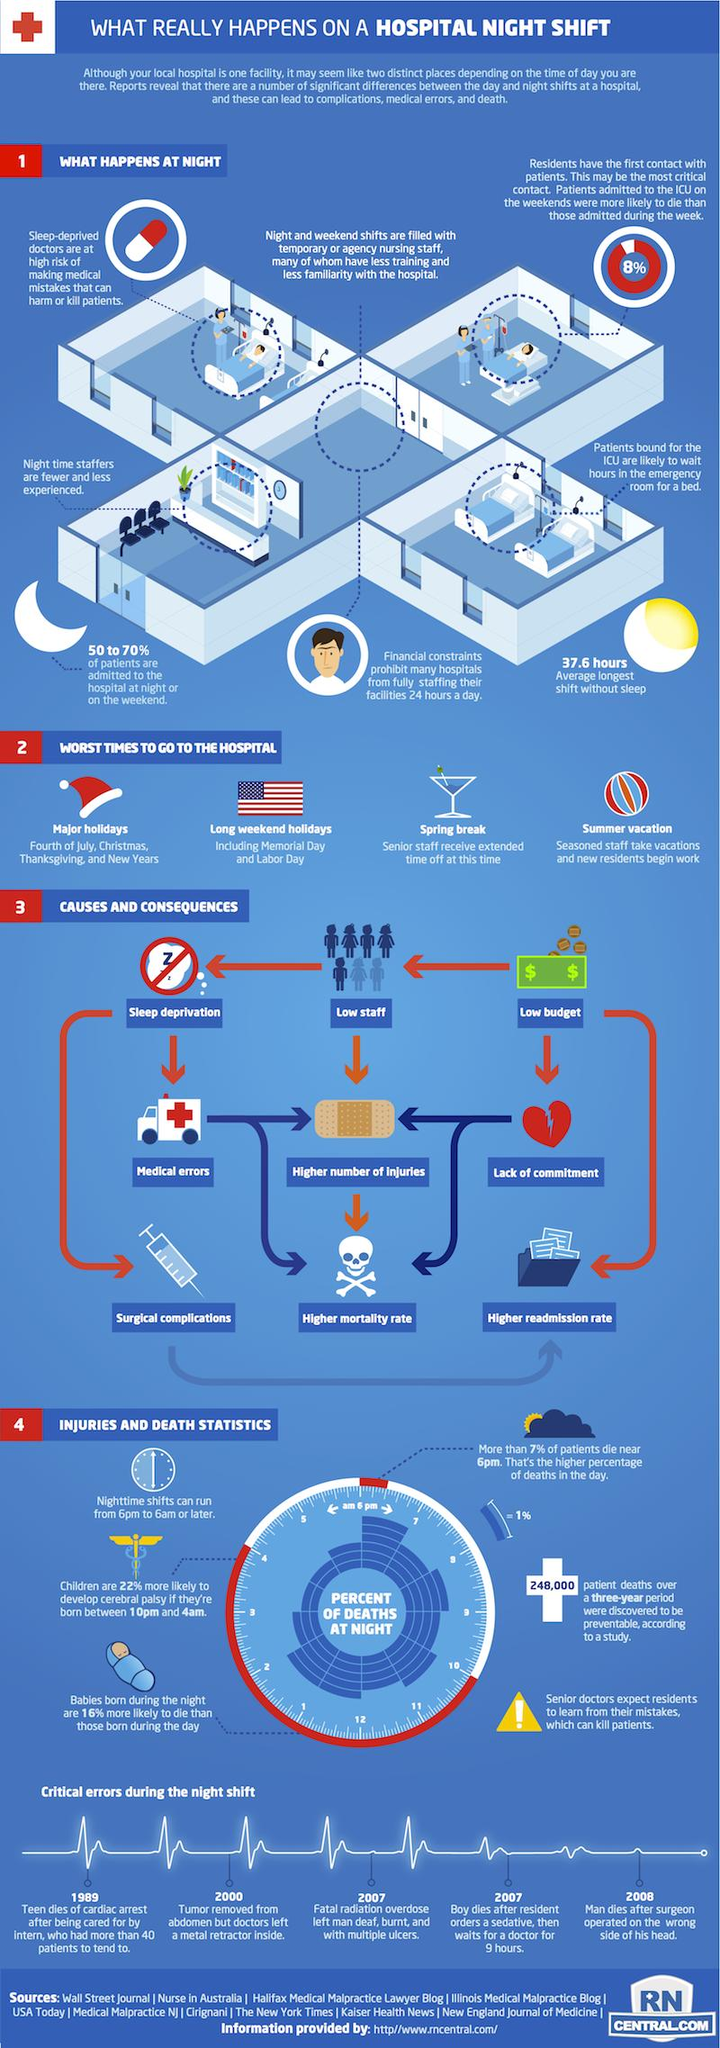List a handful of essential elements in this visual. The average longest shift worked without sleep in hospitals is 37.6 hours. 